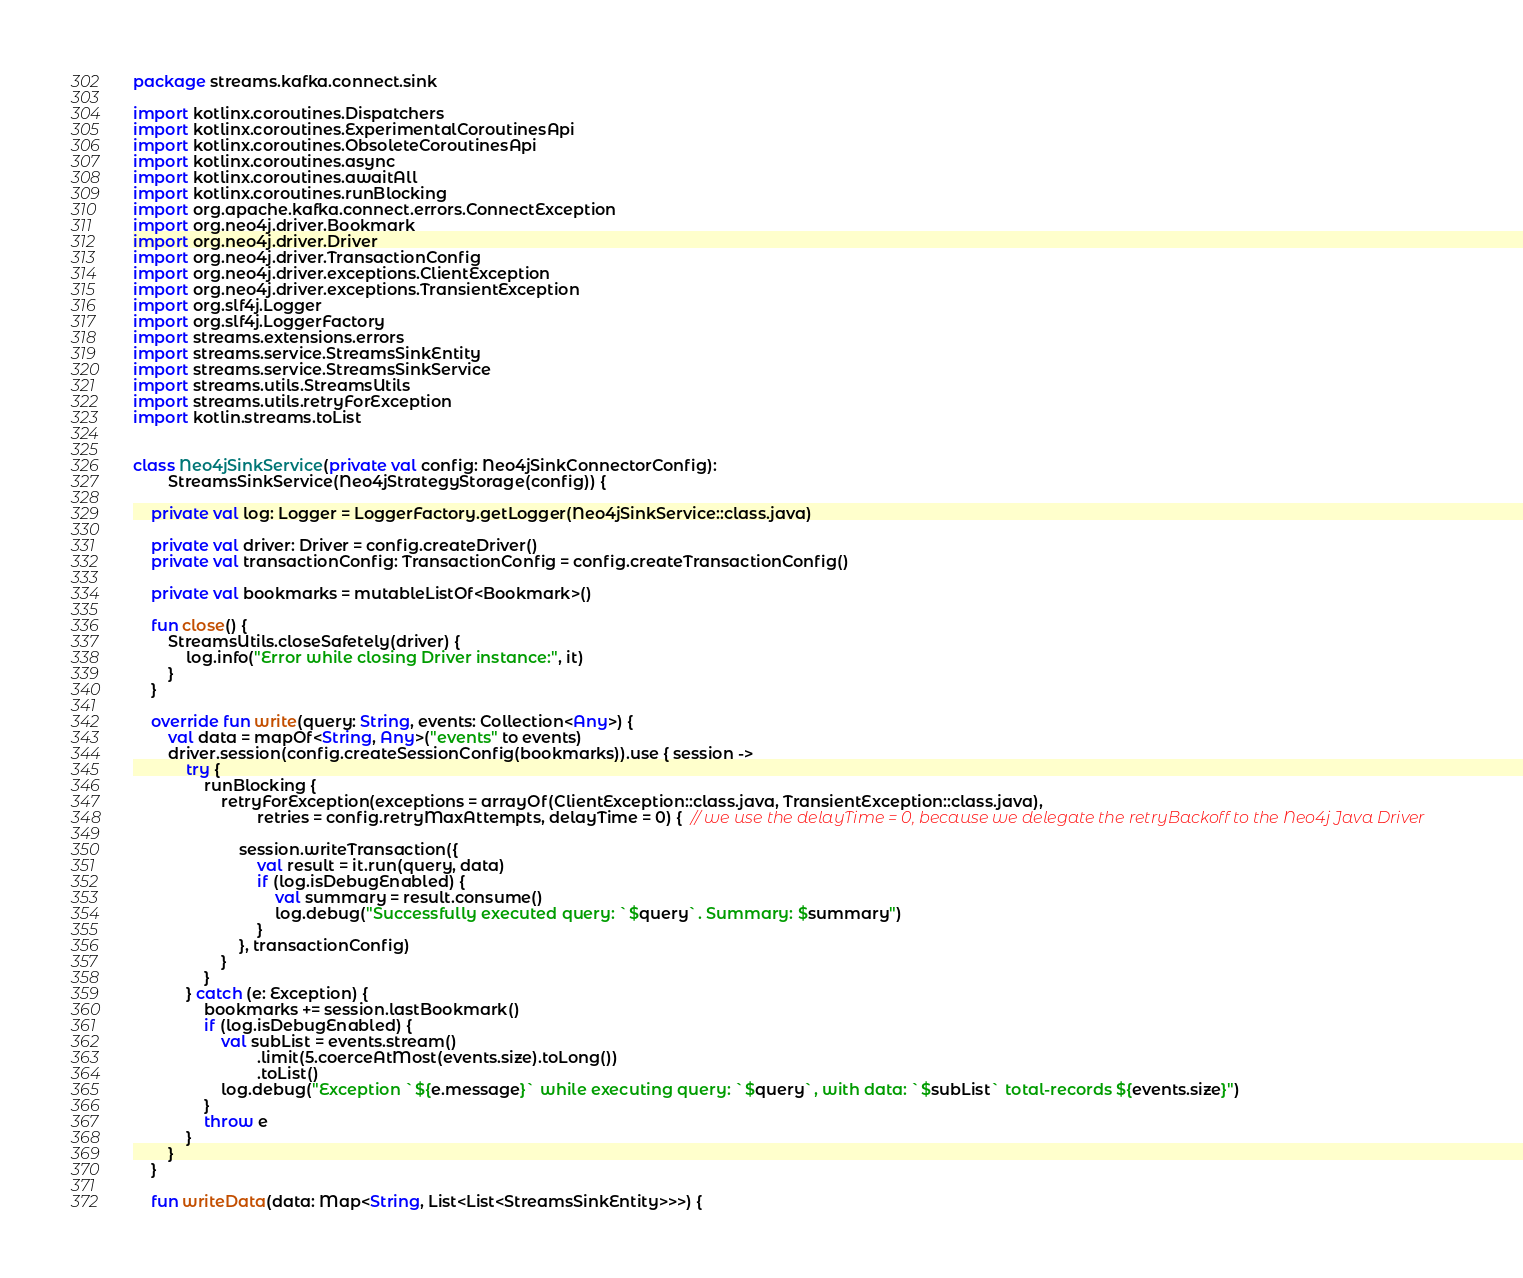<code> <loc_0><loc_0><loc_500><loc_500><_Kotlin_>package streams.kafka.connect.sink

import kotlinx.coroutines.Dispatchers
import kotlinx.coroutines.ExperimentalCoroutinesApi
import kotlinx.coroutines.ObsoleteCoroutinesApi
import kotlinx.coroutines.async
import kotlinx.coroutines.awaitAll
import kotlinx.coroutines.runBlocking
import org.apache.kafka.connect.errors.ConnectException
import org.neo4j.driver.Bookmark
import org.neo4j.driver.Driver
import org.neo4j.driver.TransactionConfig
import org.neo4j.driver.exceptions.ClientException
import org.neo4j.driver.exceptions.TransientException
import org.slf4j.Logger
import org.slf4j.LoggerFactory
import streams.extensions.errors
import streams.service.StreamsSinkEntity
import streams.service.StreamsSinkService
import streams.utils.StreamsUtils
import streams.utils.retryForException
import kotlin.streams.toList


class Neo4jSinkService(private val config: Neo4jSinkConnectorConfig):
        StreamsSinkService(Neo4jStrategyStorage(config)) {

    private val log: Logger = LoggerFactory.getLogger(Neo4jSinkService::class.java)

    private val driver: Driver = config.createDriver()
    private val transactionConfig: TransactionConfig = config.createTransactionConfig()

    private val bookmarks = mutableListOf<Bookmark>()

    fun close() {
        StreamsUtils.closeSafetely(driver) {
            log.info("Error while closing Driver instance:", it)
        }
    }

    override fun write(query: String, events: Collection<Any>) {
        val data = mapOf<String, Any>("events" to events)
        driver.session(config.createSessionConfig(bookmarks)).use { session ->
            try {
                runBlocking {
                    retryForException(exceptions = arrayOf(ClientException::class.java, TransientException::class.java),
                            retries = config.retryMaxAttempts, delayTime = 0) {  // we use the delayTime = 0, because we delegate the retryBackoff to the Neo4j Java Driver

                        session.writeTransaction({
                            val result = it.run(query, data)
                            if (log.isDebugEnabled) {
                                val summary = result.consume()
                                log.debug("Successfully executed query: `$query`. Summary: $summary")
                            }
                        }, transactionConfig)
                    }
                }
            } catch (e: Exception) {
                bookmarks += session.lastBookmark()
                if (log.isDebugEnabled) {
                    val subList = events.stream()
                            .limit(5.coerceAtMost(events.size).toLong())
                            .toList()
                    log.debug("Exception `${e.message}` while executing query: `$query`, with data: `$subList` total-records ${events.size}")
                }
                throw e
            }
        }
    }

    fun writeData(data: Map<String, List<List<StreamsSinkEntity>>>) {</code> 